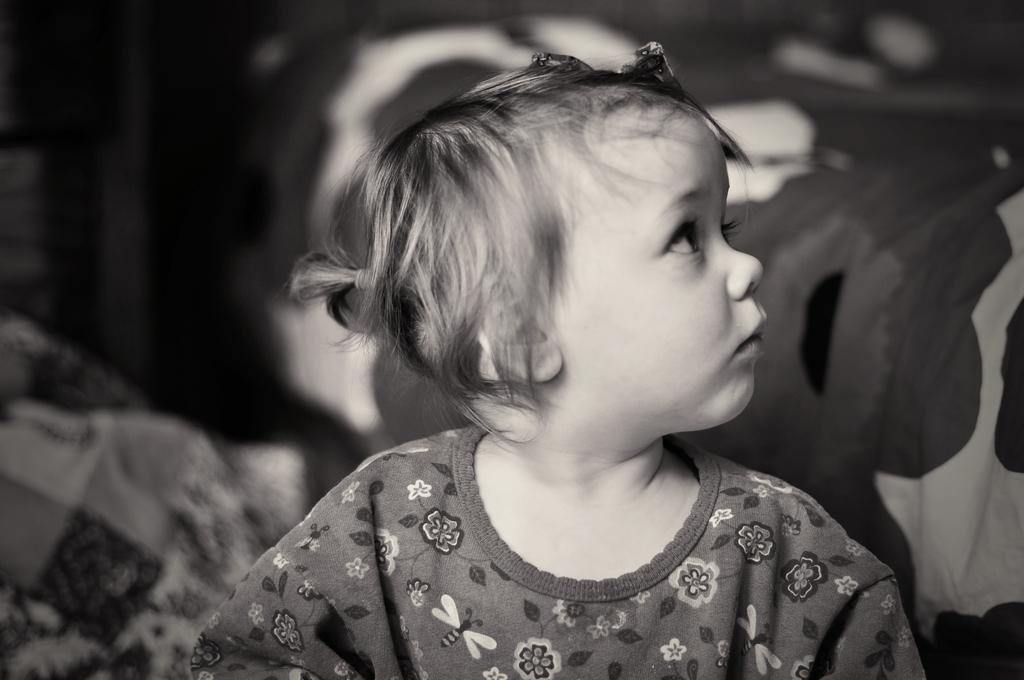What is the color scheme of the image? The image is black and white. Who or what is the main subject in the image? There is a small girl in the image. What can be seen on the right side of the image? There is a bed sheet on the right side of the image. How would you describe the background of the image? The background of the image has a blurred view. What type of cakes are being served at the family gathering in the image? There is no family gathering or cakes present in the image; it features a small girl and a blurred background. Can you tell me how many animals are visible at the zoo in the image? There is no zoo or animals present in the image; it features a small girl and a blurred background. 